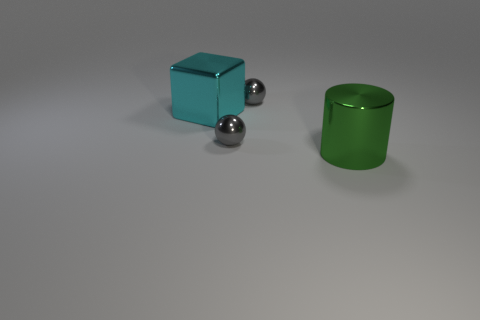Add 2 brown matte cylinders. How many objects exist? 6 Subtract all cubes. How many objects are left? 3 Add 2 small purple shiny balls. How many small purple shiny balls exist? 2 Subtract 0 red cylinders. How many objects are left? 4 Subtract all green metal things. Subtract all cylinders. How many objects are left? 2 Add 1 big green metal things. How many big green metal things are left? 2 